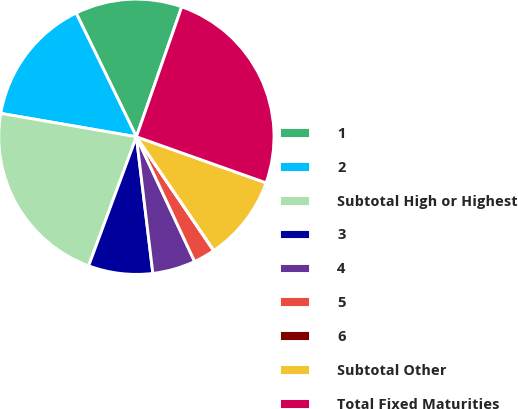Convert chart. <chart><loc_0><loc_0><loc_500><loc_500><pie_chart><fcel>1<fcel>2<fcel>Subtotal High or Highest<fcel>3<fcel>4<fcel>5<fcel>6<fcel>Subtotal Other<fcel>Total Fixed Maturities<nl><fcel>12.56%<fcel>15.07%<fcel>22.08%<fcel>7.55%<fcel>5.04%<fcel>2.54%<fcel>0.03%<fcel>10.05%<fcel>25.09%<nl></chart> 